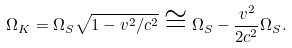Convert formula to latex. <formula><loc_0><loc_0><loc_500><loc_500>\Omega _ { K } = \Omega _ { S } \sqrt { 1 - v ^ { 2 } / c ^ { 2 } } \cong \Omega _ { S } - \frac { { v ^ { 2 } } } { { 2 c ^ { 2 } } } \Omega _ { S } .</formula> 